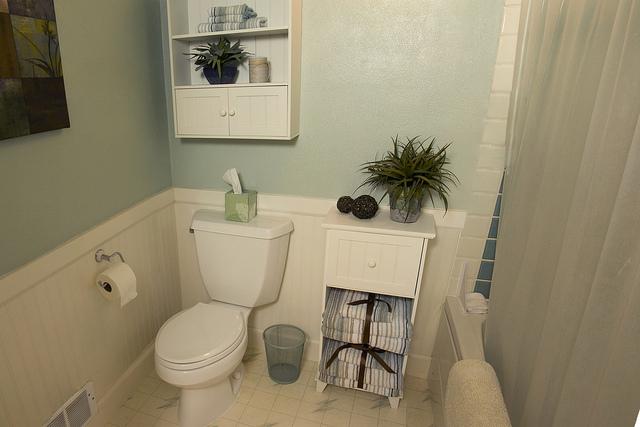Is the shower curtain hanging normally?
Be succinct. Yes. How many plants are there?
Quick response, please. 2. How many towels are there?
Short answer required. 5. What room of the house is this?
Quick response, please. Bathroom. What has been hung on the wall?
Give a very brief answer. Cabinet. Is the toilet paper roll dispenser over the top?
Be succinct. Yes. How many towels are pictured?
Give a very brief answer. 6. 